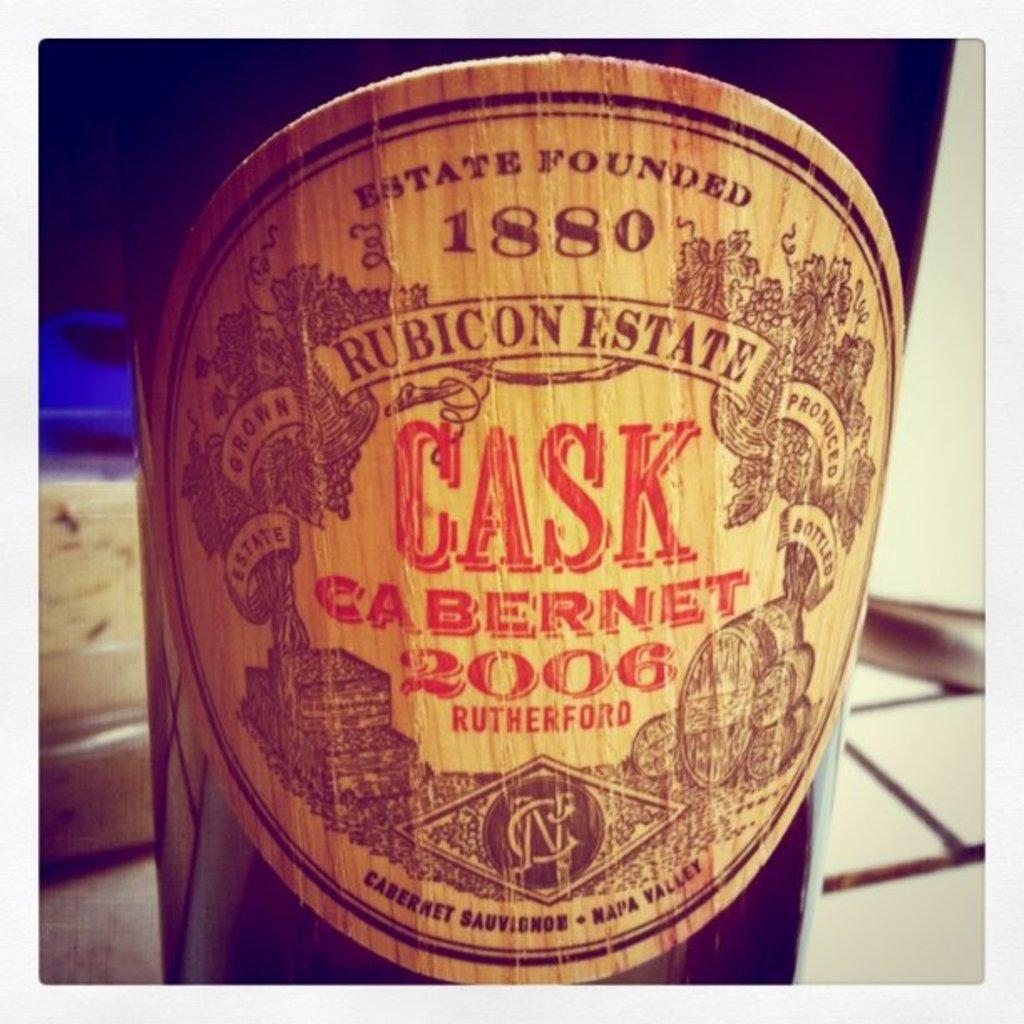<image>
Summarize the visual content of the image. a close up of a wine bottle label reading CASK 2006 